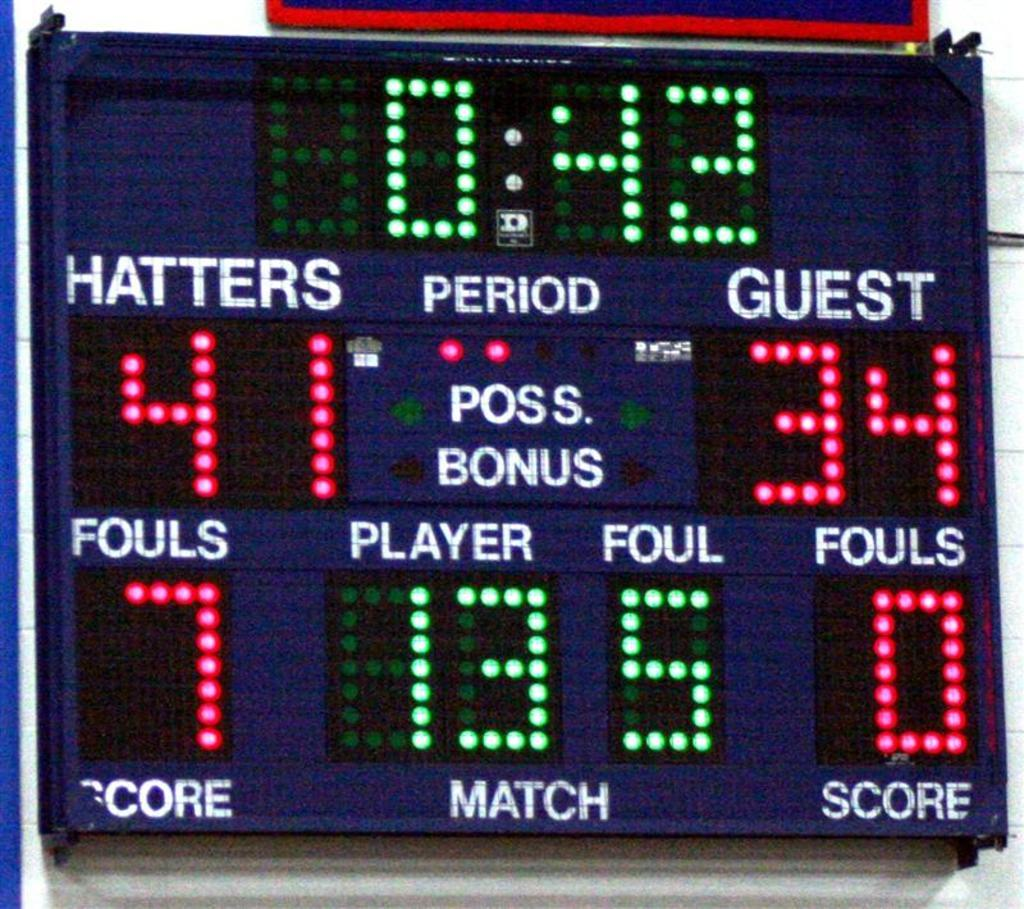Provide a one-sentence caption for the provided image. A scoreboard that says 42 seconds left and score 41 to 34. 